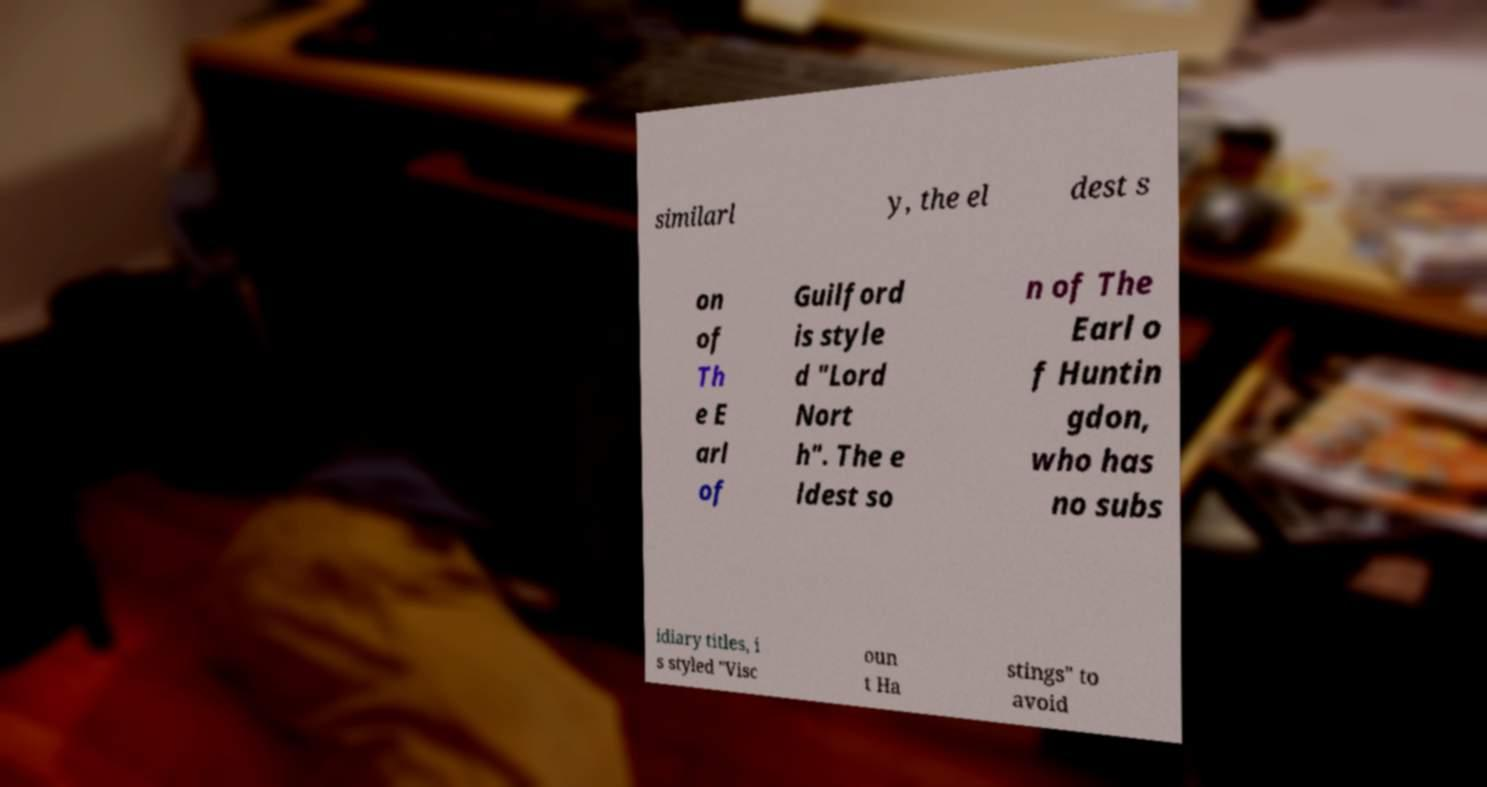Can you read and provide the text displayed in the image?This photo seems to have some interesting text. Can you extract and type it out for me? similarl y, the el dest s on of Th e E arl of Guilford is style d "Lord Nort h". The e ldest so n of The Earl o f Huntin gdon, who has no subs idiary titles, i s styled "Visc oun t Ha stings" to avoid 